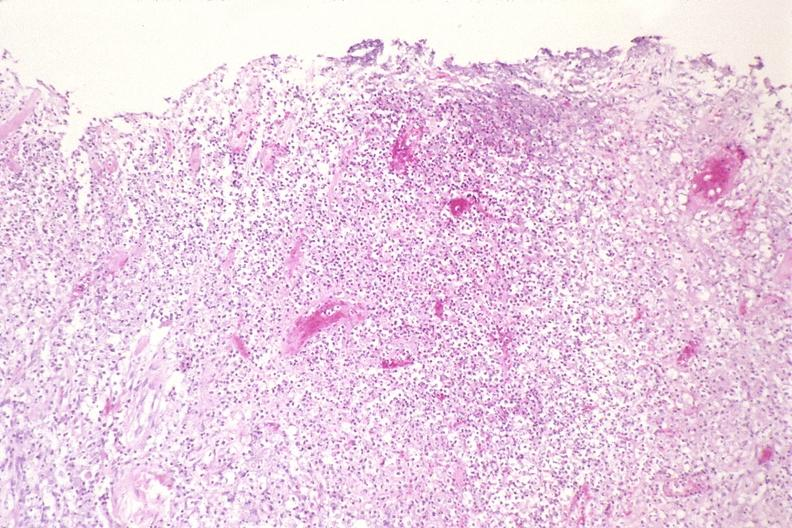s mucicarmine present?
Answer the question using a single word or phrase. No 